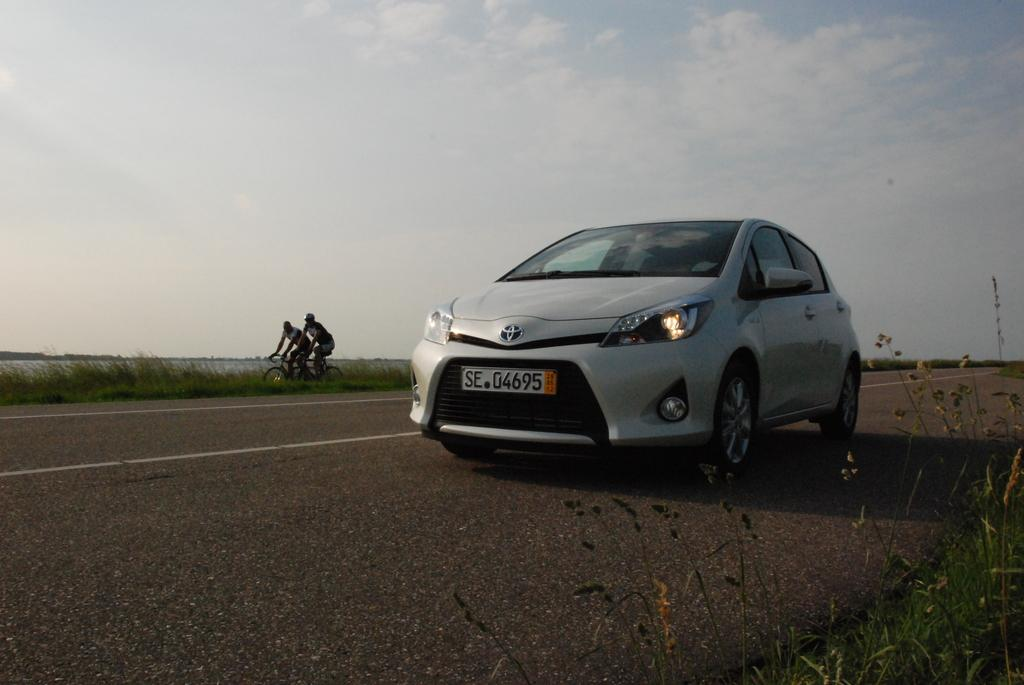What is the main subject of the image? The main subject of the image is a car. What is the car doing in the image? The car is moving on a road. What can be seen on either side of the road? Grass is present on either side of the road. Are there any other people or vehicles in the image? Yes, there are two persons cycling behind the car. What is visible in the background of the image? The sky is visible in the image, and clouds are present in the sky. How many lizards can be seen crawling on the car in the image? There are no lizards present in the image; it features a car moving on a road with two cyclists behind it. What type of hose is connected to the car's exhaust pipe in the image? There is no hose connected to the car's exhaust pipe in the image. 